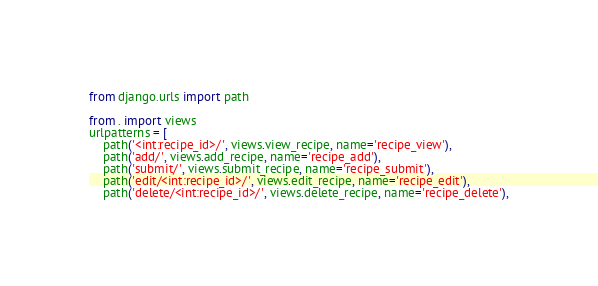<code> <loc_0><loc_0><loc_500><loc_500><_Python_>from django.urls import path

from . import views
urlpatterns = [
    path('<int:recipe_id>/', views.view_recipe, name='recipe_view'),
    path('add/', views.add_recipe, name='recipe_add'),
    path('submit/', views.submit_recipe, name='recipe_submit'),
    path('edit/<int:recipe_id>/', views.edit_recipe, name='recipe_edit'),
    path('delete/<int:recipe_id>/', views.delete_recipe, name='recipe_delete'),</code> 